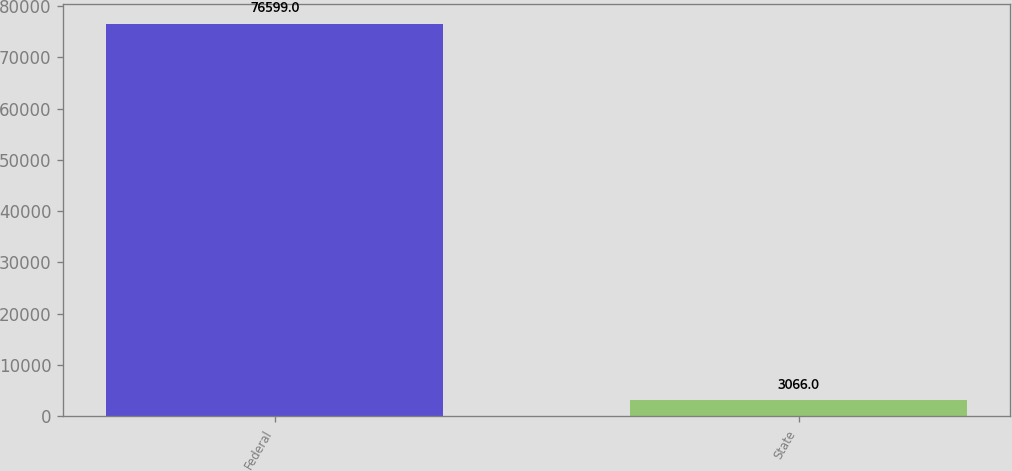Convert chart. <chart><loc_0><loc_0><loc_500><loc_500><bar_chart><fcel>Federal<fcel>State<nl><fcel>76599<fcel>3066<nl></chart> 